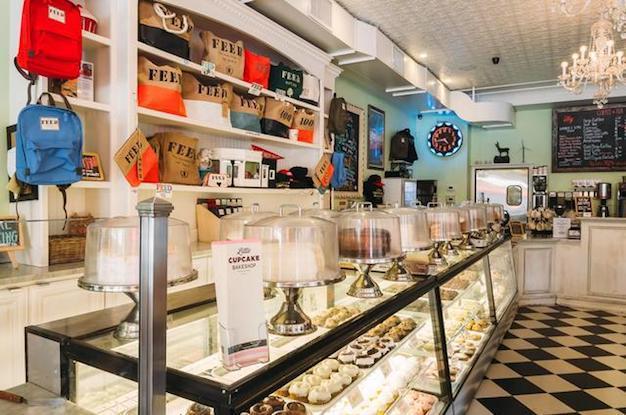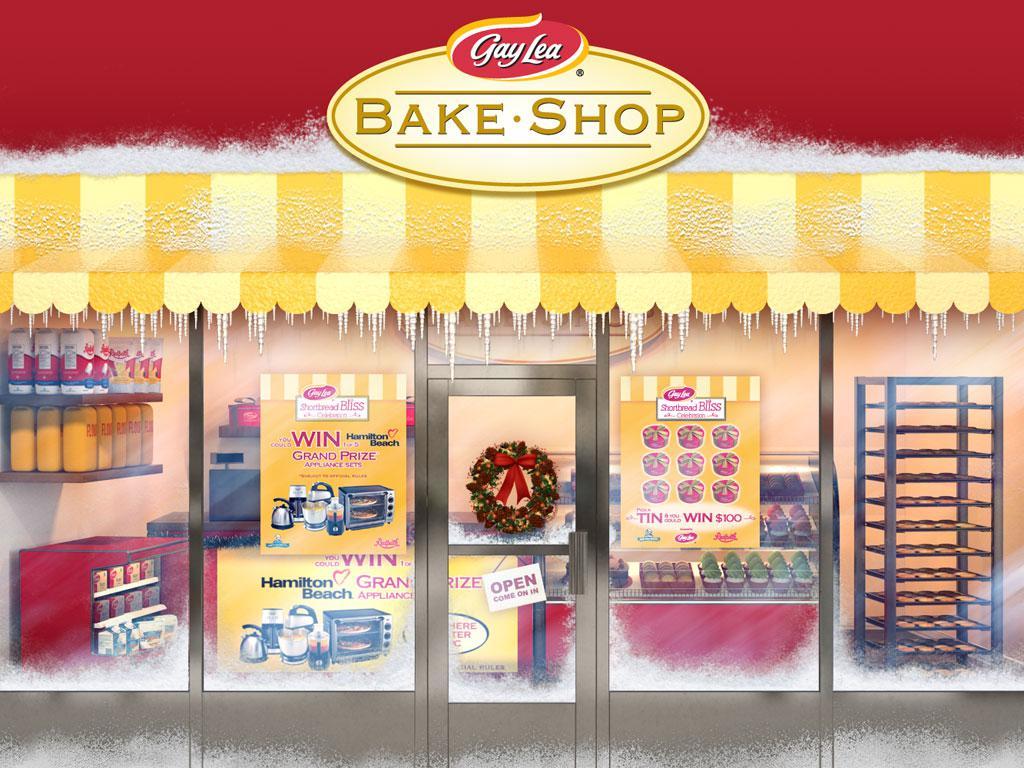The first image is the image on the left, the second image is the image on the right. Analyze the images presented: Is the assertion "One of the images shows the flooring in front of a glass fronted display case." valid? Answer yes or no. Yes. 